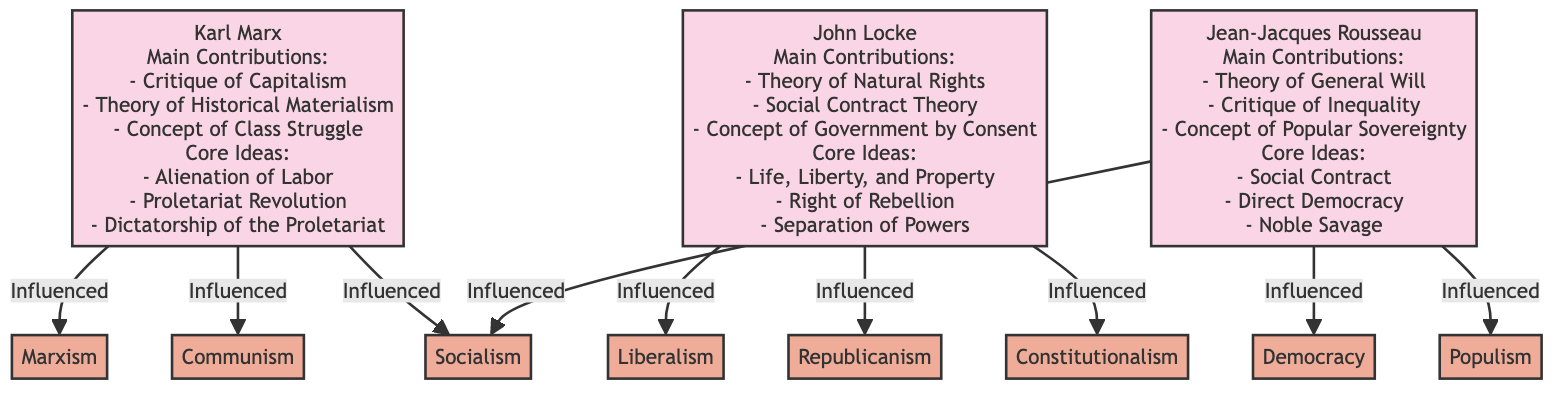What are the main contributions of Karl Marx? The diagram lists three main contributions of Karl Marx: Critique of Capitalism, Theory of Historical Materialism, and Concept of Class Struggle.
Answer: Critique of Capitalism, Theory of Historical Materialism, Concept of Class Struggle What ideologies are influenced by John Locke? The diagram indicates that John Locke influences three ideologies: Liberalism, Republicanism, and Constitutionalism.
Answer: Liberalism, Republicanism, Constitutionalism How many core ideas are attributed to Jean-Jacques Rousseau? The diagram details three core ideas for Jean-Jacques Rousseau: Social Contract, Direct Democracy, and Noble Savage. Therefore, it can be concluded that there are three core ideas.
Answer: 3 Which political ideology is influenced by the theory of general will? The diagram connects Jean-Jacques Rousseau to the ideology of Democracy, stating it is based on the theory of general will and popular sovereignty.
Answer: Democracy What relationship exists between Karl Marx and Communism? The diagram shows an arrow from Karl Marx to Communism, indicating that Communism is influenced by Marx's theories of historical materialism and class struggle.
Answer: Influenced by theory of historical materialism and class struggle Which philosopher's core idea includes life, liberty, and property? According to the diagram, the core idea of Life, Liberty, and Property is specifically attributed to John Locke.
Answer: John Locke How many ideologies does Rousseau influence? The diagram outlines three ideologies influenced by Jean-Jacques Rousseau: Democracy, Socialism, and Populism, thus indicating that Rousseau influences three ideologies.
Answer: 3 What common theme do John Locke and Karl Marx share in their contributions? The diagram highlights that both theorists have concepts related to social governance; Locke discusses Government by Consent, while Marx emphasizes class struggle and revolution, reflecting a focus on societal structures and individual rights versus class rights.
Answer: Governance and societal structures Which major concept of Rousseau critiques inequality? The diagram explicitly lists Critique of Inequality as one of Rousseau's main contributions, showing that this concept is directly related to his work.
Answer: Critique of Inequality 